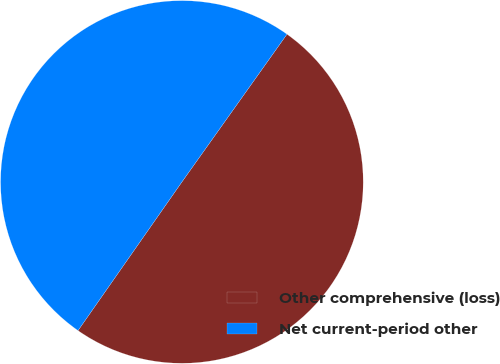<chart> <loc_0><loc_0><loc_500><loc_500><pie_chart><fcel>Other comprehensive (loss)<fcel>Net current-period other<nl><fcel>49.87%<fcel>50.13%<nl></chart> 